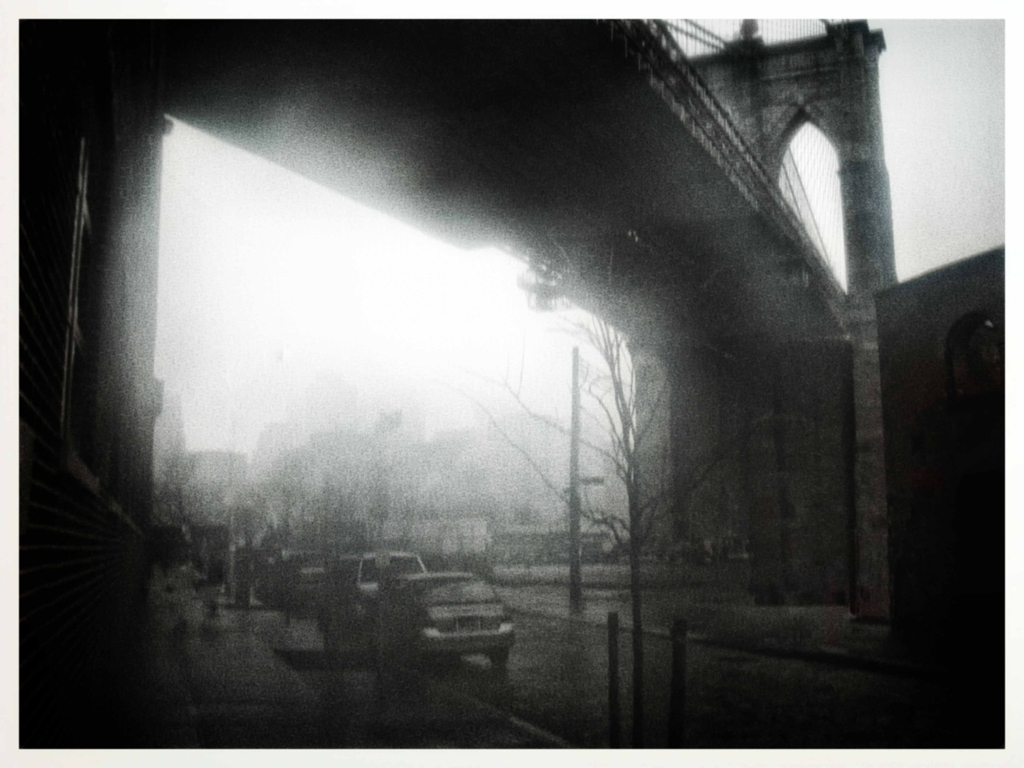What architectural features can you identify in the image? In the foreground, we can see the underpass of a bridge with its robust supports and arches creating a framing effect. The bridge itself appears to be a suspension bridge, identifiable by the large, towering columns and the suggestion of cables—likely a well-known landmark. The buildings in the background have a more modern, utilitarian design, characterized by their flat surfaces and right angles. 